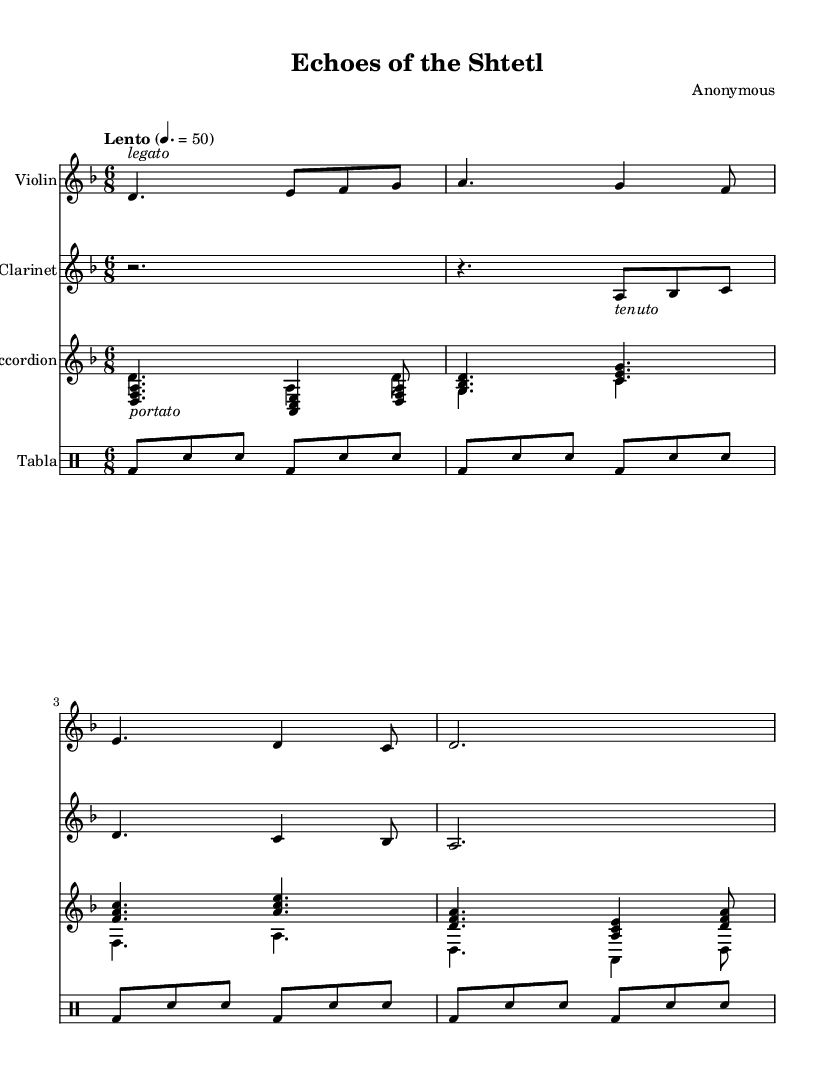What is the key signature of this music? The key signature is indicated by the key signature at the beginning of the piece. Here, the key of D minor is shown, which typically contains one flat (B flat).
Answer: D minor What is the time signature of this music? The time signature can be found at the beginning of the music, which shows the grouping of beats. In this case, it is 6/8, meaning there are six eighth notes in a measure.
Answer: 6/8 What is the tempo marking for this composition? The tempo marking is displayed above the staff in text format. It indicates the speed of the piece, which is "Lento" at a quarter note equals 50 beats per minute.
Answer: Lento How many measures are in the Violin part? By counting the individual segments separated by bar lines, we can determine the number of measures. The Violin part contains six measures in total.
Answer: Six Which instrument plays the rhythmic pattern resembling a traditional Jewish drum? The rhythmic pattern can be identified by looking for the sections typically used for percussion. The tabla is the instrument that provides the traditional drum rhythm in this piece.
Answer: Tabla What dynamics are indicated for the Clarinet? Dynamics are often notated above or below the notes. The Clarinet part shows a dynamic marking of "p" which stands for piano, indicating a soft volume level.
Answer: Piano What is the texture of the music in terms of instrumentation? To determine the texture, we look at how many different instrumental parts are contributing to the overall sound. This composition features four distinct instrumental parts: Violin, Clarinet, Accordion, and Tabla. The texture can thus be described as polyphonic.
Answer: Polyphonic 